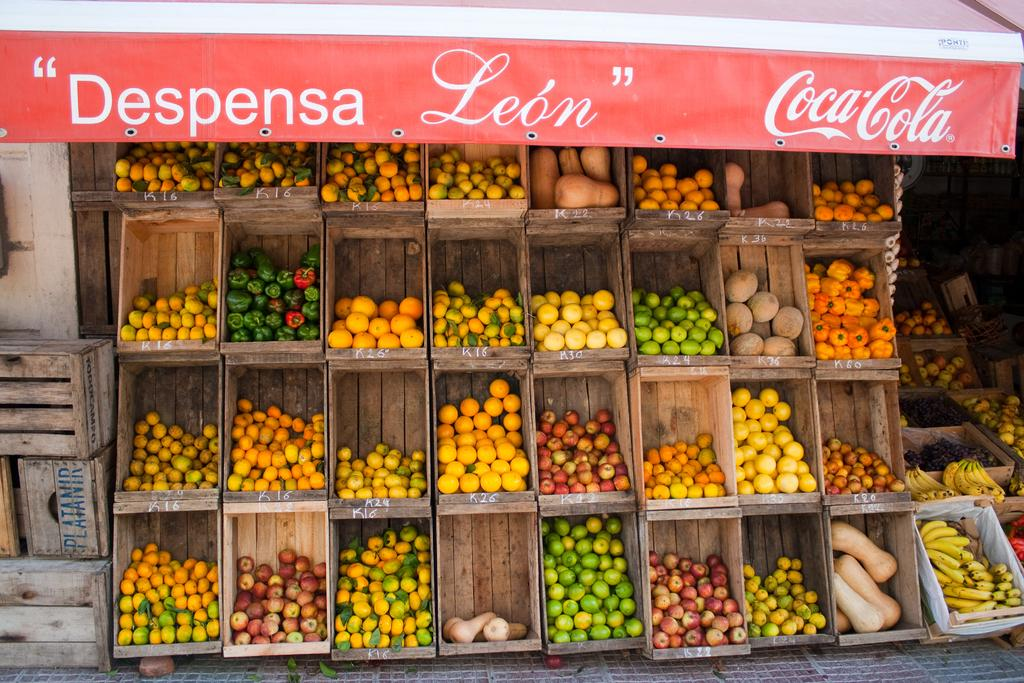What type of store is depicted in the image? There is a fruit store in the image. How are the fruit boxes arranged in the image? The fruit boxes are placed one on the other in the image. What type of screw is used to hold the fruit boxes together in the image? There is no screw visible in the image, as the fruit boxes are simply placed one on the other. 